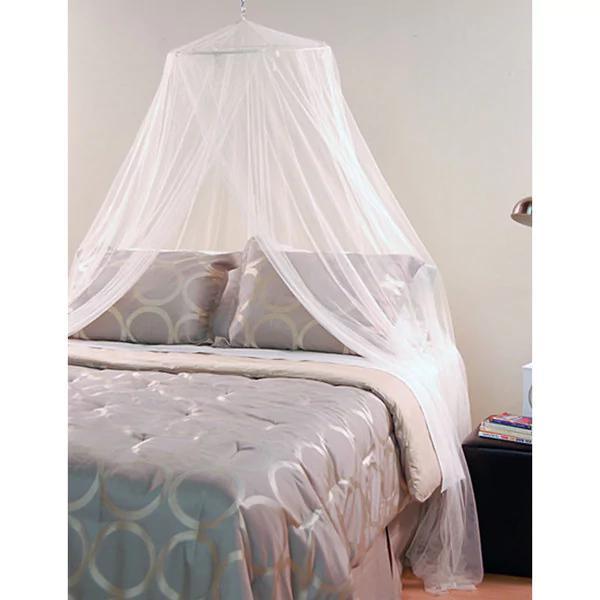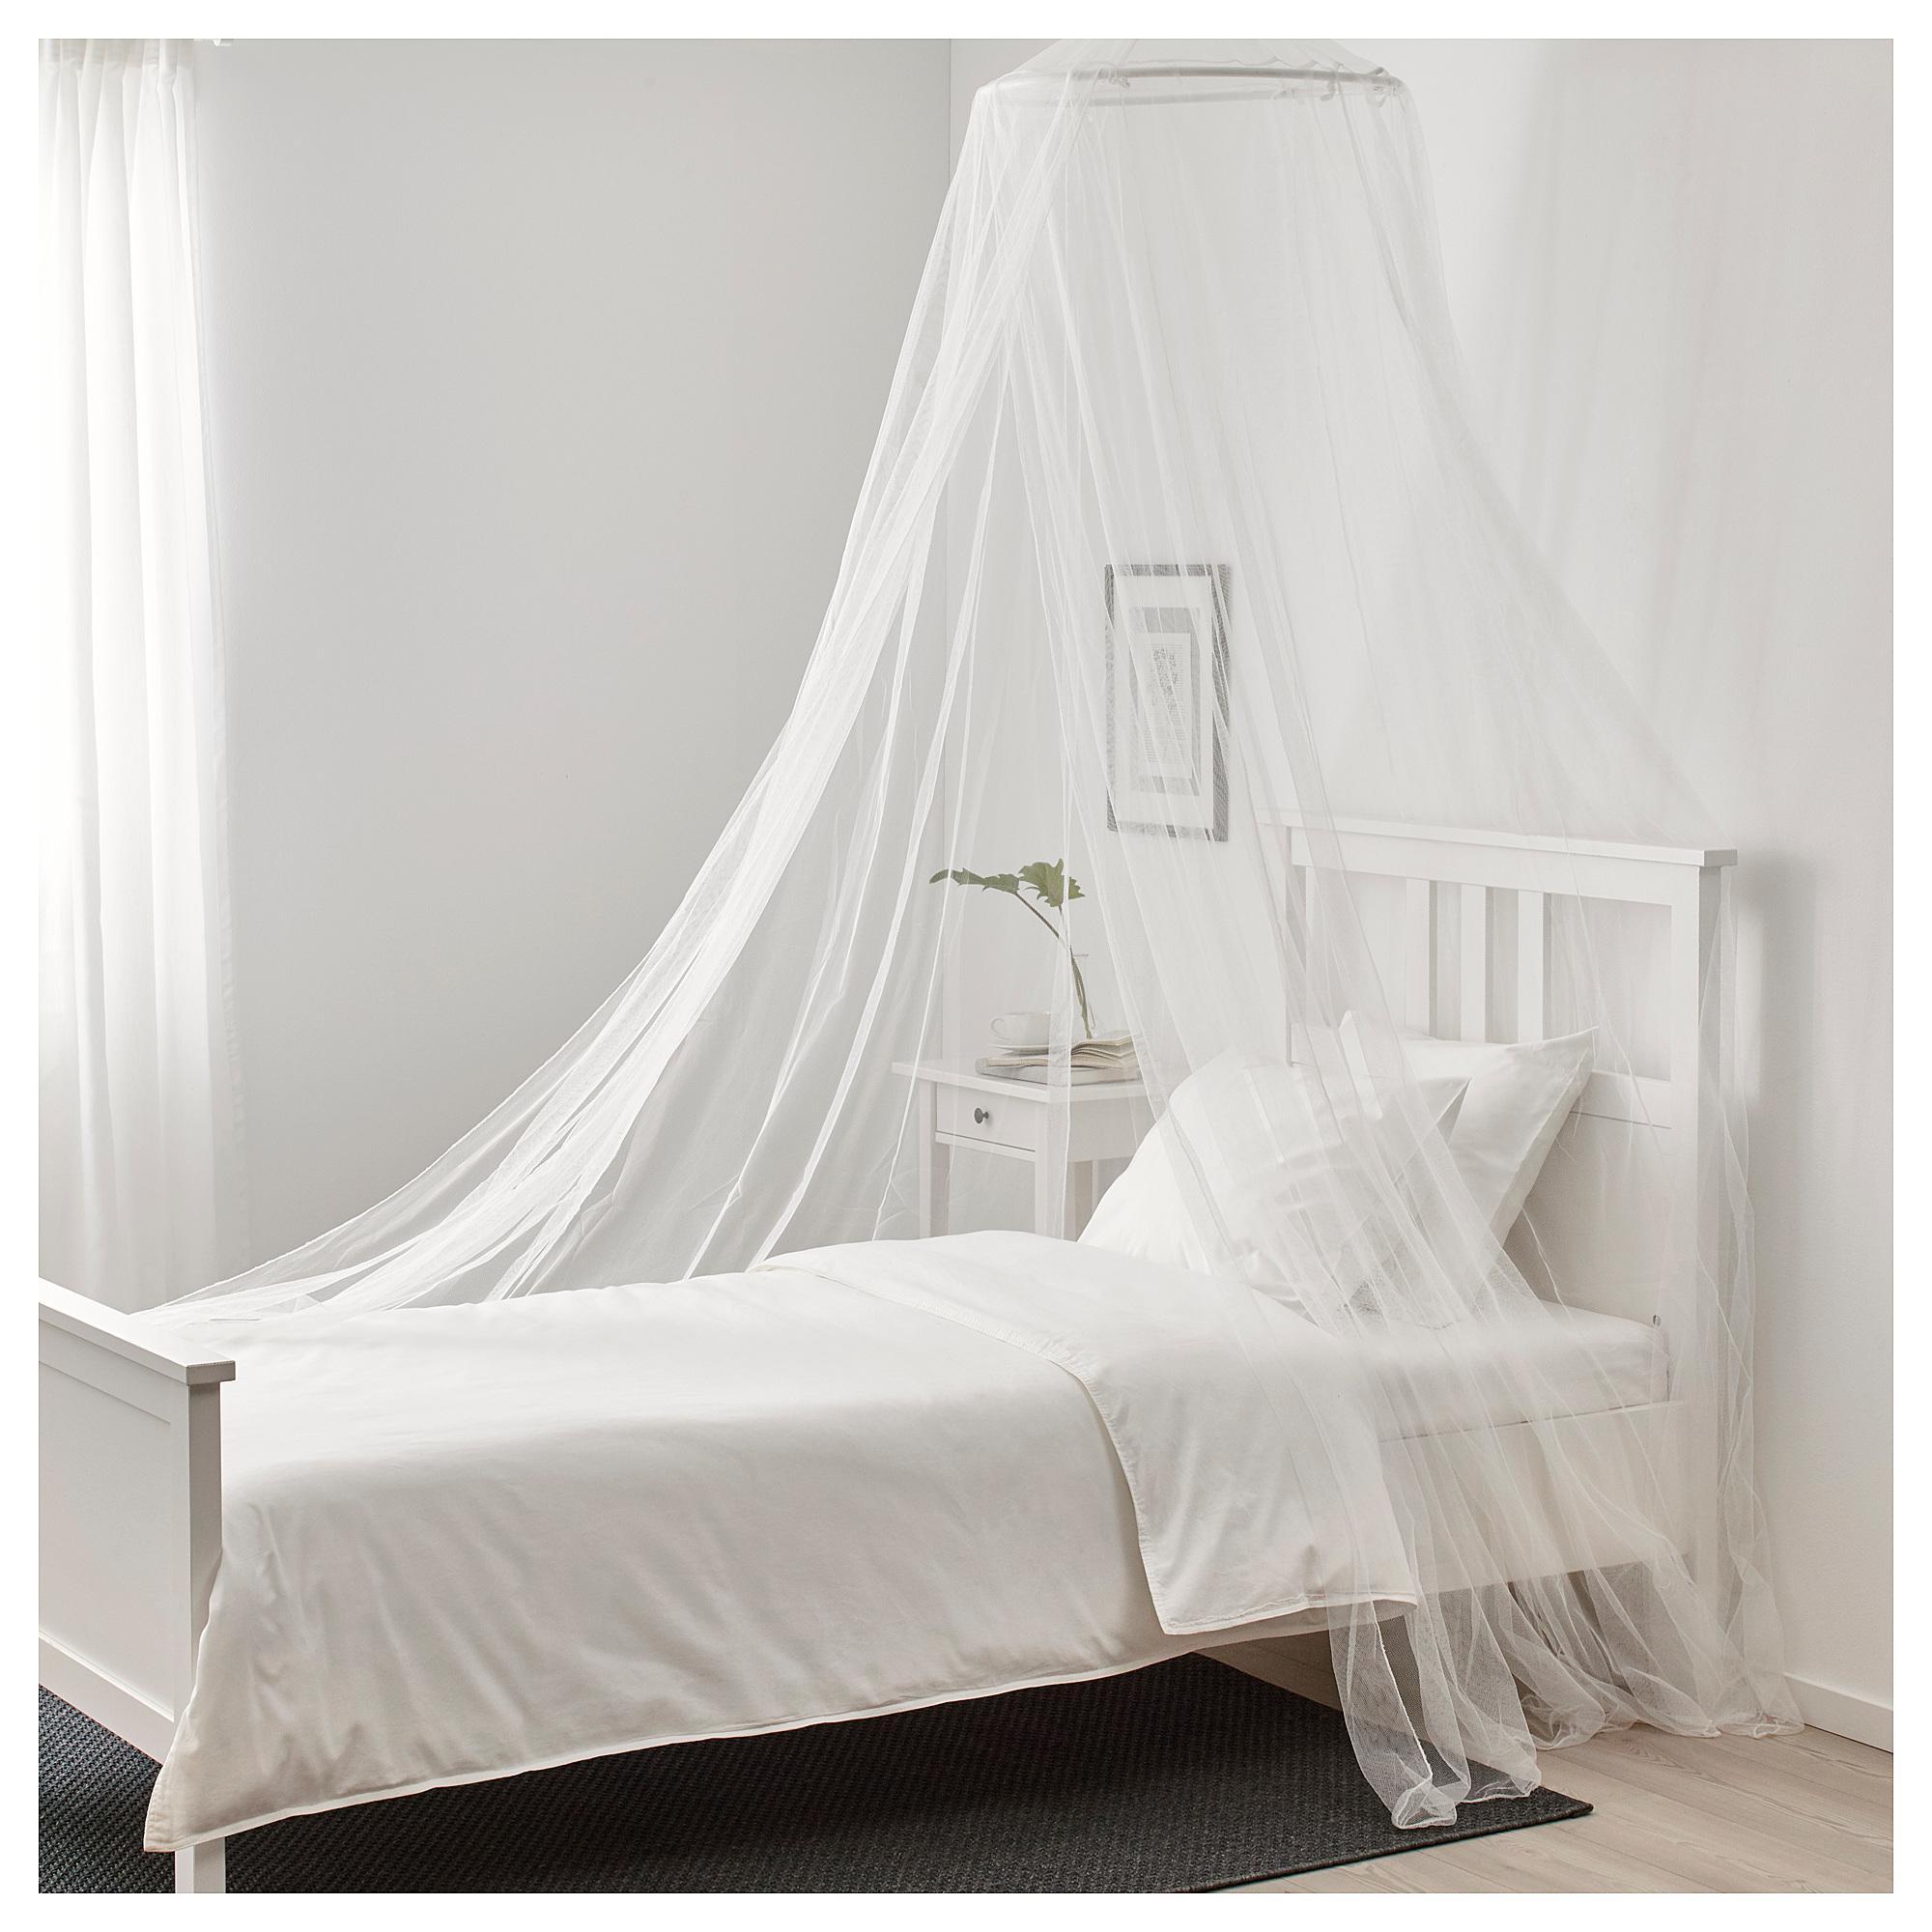The first image is the image on the left, the second image is the image on the right. Considering the images on both sides, is "All of the curtains are draped above regular beds." valid? Answer yes or no. Yes. The first image is the image on the left, the second image is the image on the right. Evaluate the accuracy of this statement regarding the images: "There are two beds in total.". Is it true? Answer yes or no. Yes. 